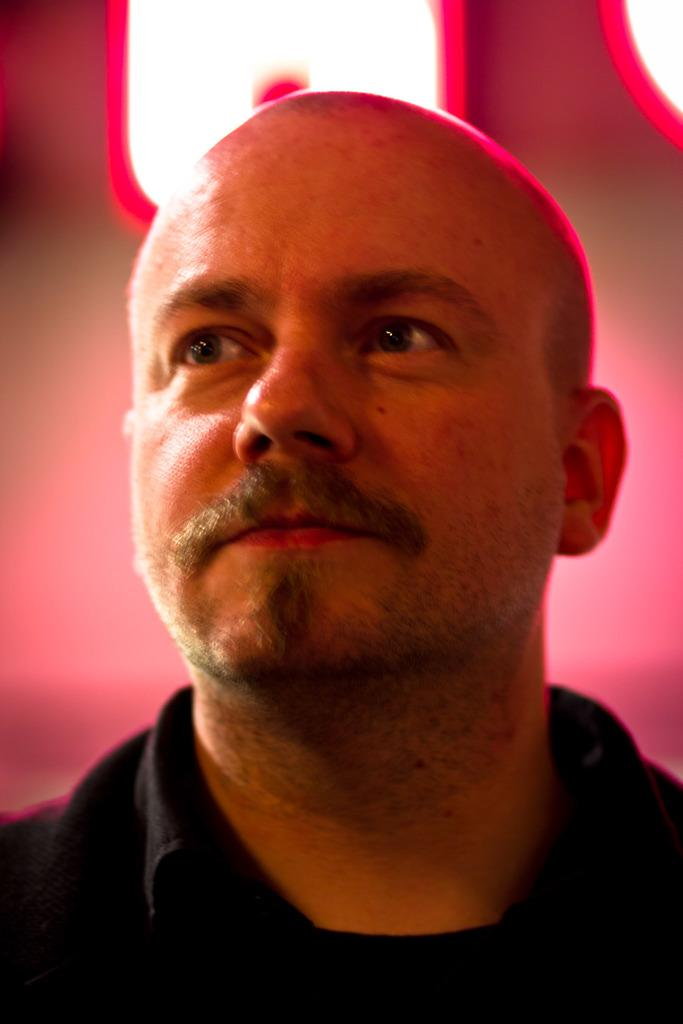What is the main subject in the foreground of the image? There is a person in the foreground of the image. Can you describe the background of the image? The background of the image is blurred. What type of skirt is the person wearing in the image? There is no information about the person's clothing, including any skirt, in the image. Is the person walking on a sidewalk in the image? There is no sidewalk visible in the image. Can you see a baseball game happening in the background of the image? There is no baseball game or any reference to baseball in the image. 